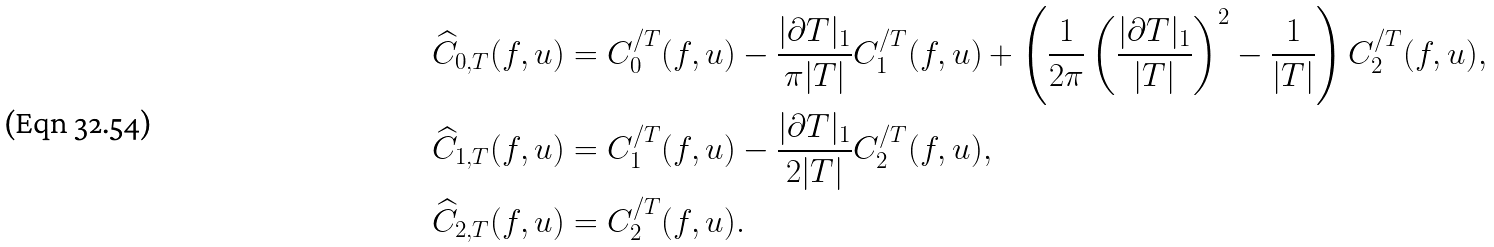<formula> <loc_0><loc_0><loc_500><loc_500>\widehat { C } _ { 0 , T } ( f , u ) & = C ^ { / T } _ { 0 } ( f , u ) - \frac { | \partial T | _ { 1 } } { \pi | T | } C ^ { / T } _ { 1 } ( f , u ) + \left ( \frac { 1 } { 2 \pi } \left ( \frac { | \partial T | _ { 1 } } { | T | } \right ) ^ { 2 } - \frac { 1 } { | T | } \right ) C ^ { / T } _ { 2 } ( f , u ) , \\ \widehat { C } _ { 1 , T } ( f , u ) & = C ^ { / T } _ { 1 } ( f , u ) - \frac { | \partial T | _ { 1 } } { 2 | T | } C ^ { / T } _ { 2 } ( f , u ) , \\ \widehat { C } _ { 2 , T } ( f , u ) & = C ^ { / T } _ { 2 } ( f , u ) .</formula> 